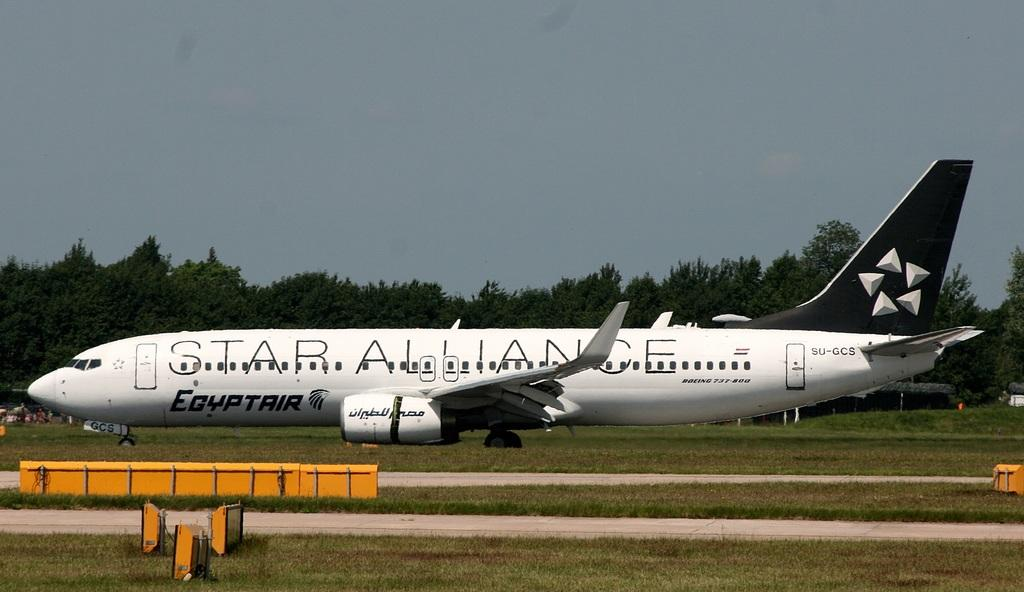<image>
Create a compact narrative representing the image presented. a white plane that has star alliance on the side of it 